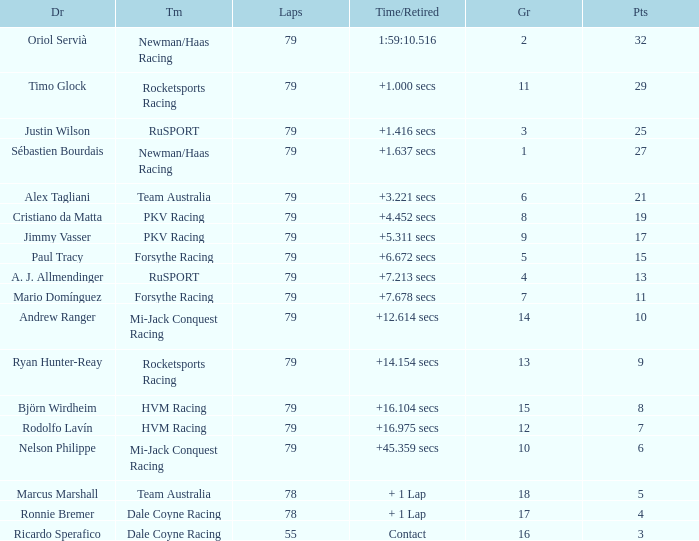Which points has the driver Paul Tracy? 15.0. 